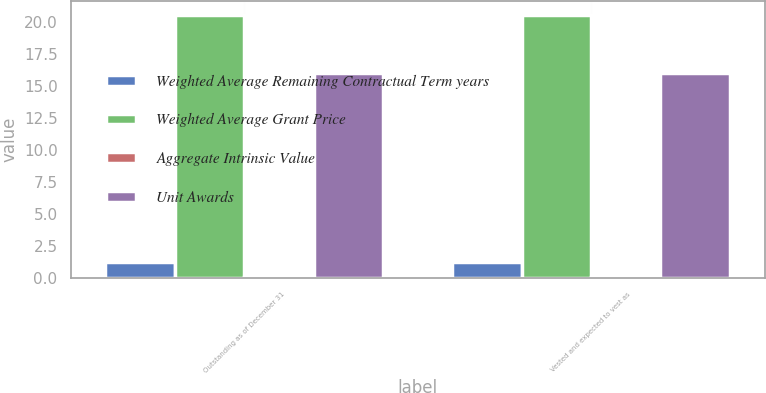Convert chart. <chart><loc_0><loc_0><loc_500><loc_500><stacked_bar_chart><ecel><fcel>Outstanding as of December 31<fcel>Vested and expected to vest as<nl><fcel>Weighted Average Remaining Contractual Term years<fcel>1.2<fcel>1.2<nl><fcel>Weighted Average Grant Price<fcel>20.59<fcel>20.59<nl><fcel>Aggregate Intrinsic Value<fcel>0.01<fcel>0.01<nl><fcel>Unit Awards<fcel>16<fcel>16<nl></chart> 